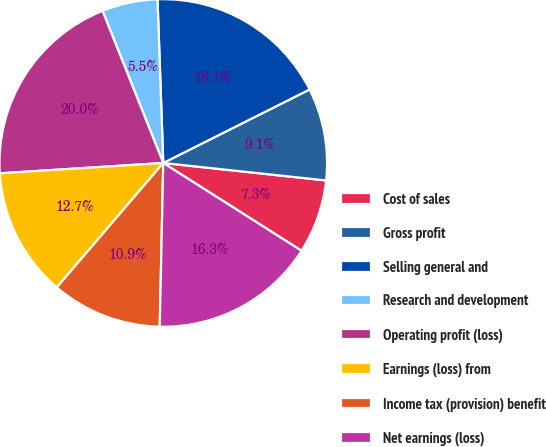Convert chart to OTSL. <chart><loc_0><loc_0><loc_500><loc_500><pie_chart><fcel>Cost of sales<fcel>Gross profit<fcel>Selling general and<fcel>Research and development<fcel>Operating profit (loss)<fcel>Earnings (loss) from<fcel>Income tax (provision) benefit<fcel>Net earnings (loss)<nl><fcel>7.3%<fcel>9.11%<fcel>18.15%<fcel>5.49%<fcel>19.96%<fcel>12.73%<fcel>10.92%<fcel>16.34%<nl></chart> 